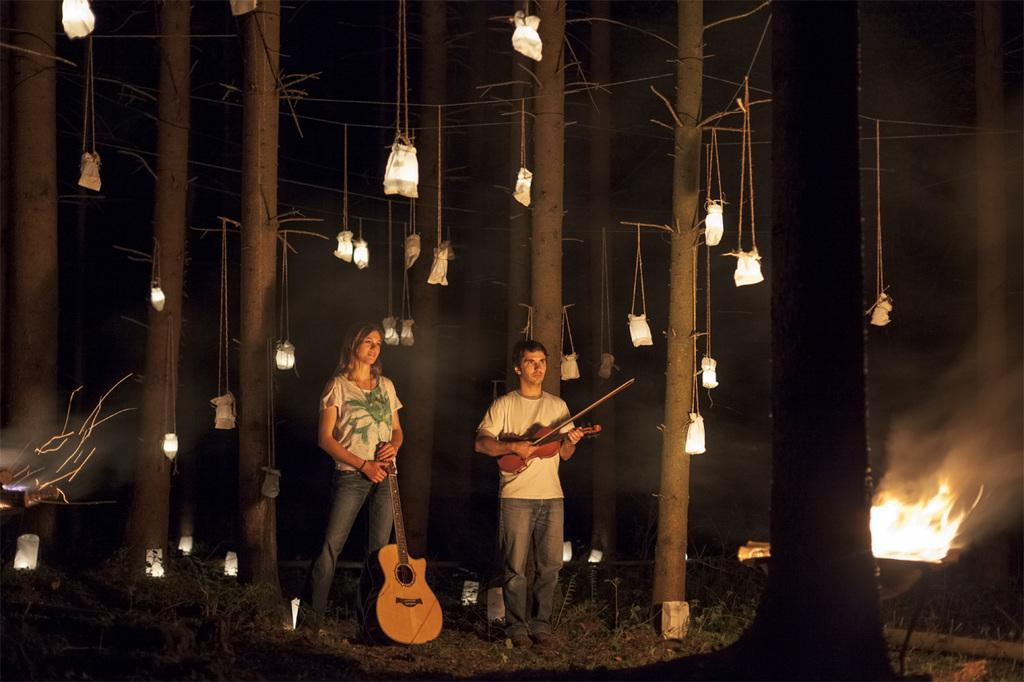What is the man holding in the image? The man is holding a violin. What instrument is the woman holding in the image? The woman is holding a guitar. Can you describe the setting where the man and woman are located? The man and woman are standing in front of a building. How fast is the man driving the car in the image? There is no car or driving activity present in the image. What is the value of the painting in the image? There is no reference to a painting or its value in the image. 